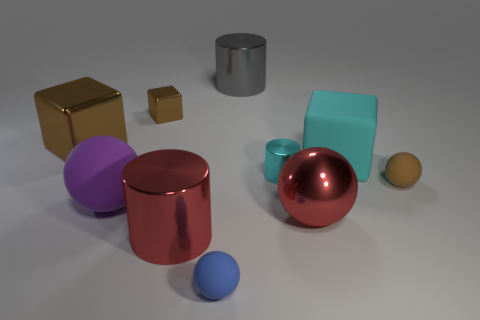Subtract all cyan rubber blocks. How many blocks are left? 2 Subtract all yellow cylinders. How many brown blocks are left? 2 Subtract 1 cubes. How many cubes are left? 2 Subtract all purple spheres. How many spheres are left? 3 Subtract all red spheres. Subtract all blue cylinders. How many spheres are left? 3 Subtract all balls. How many objects are left? 6 Subtract 1 gray cylinders. How many objects are left? 9 Subtract all tiny blue rubber spheres. Subtract all tiny cyan metal objects. How many objects are left? 8 Add 9 purple things. How many purple things are left? 10 Add 1 blocks. How many blocks exist? 4 